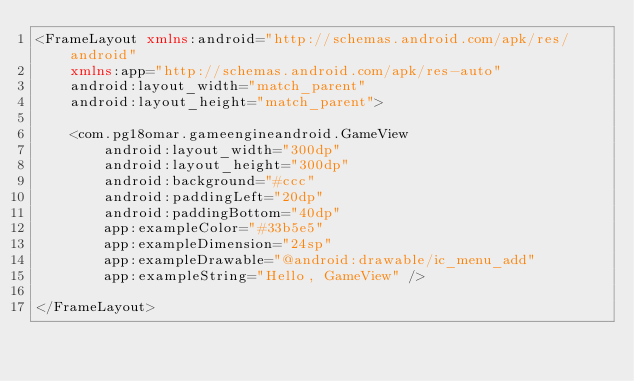Convert code to text. <code><loc_0><loc_0><loc_500><loc_500><_XML_><FrameLayout xmlns:android="http://schemas.android.com/apk/res/android"
    xmlns:app="http://schemas.android.com/apk/res-auto"
    android:layout_width="match_parent"
    android:layout_height="match_parent">

    <com.pg18omar.gameengineandroid.GameView
        android:layout_width="300dp"
        android:layout_height="300dp"
        android:background="#ccc"
        android:paddingLeft="20dp"
        android:paddingBottom="40dp"
        app:exampleColor="#33b5e5"
        app:exampleDimension="24sp"
        app:exampleDrawable="@android:drawable/ic_menu_add"
        app:exampleString="Hello, GameView" />

</FrameLayout>
</code> 